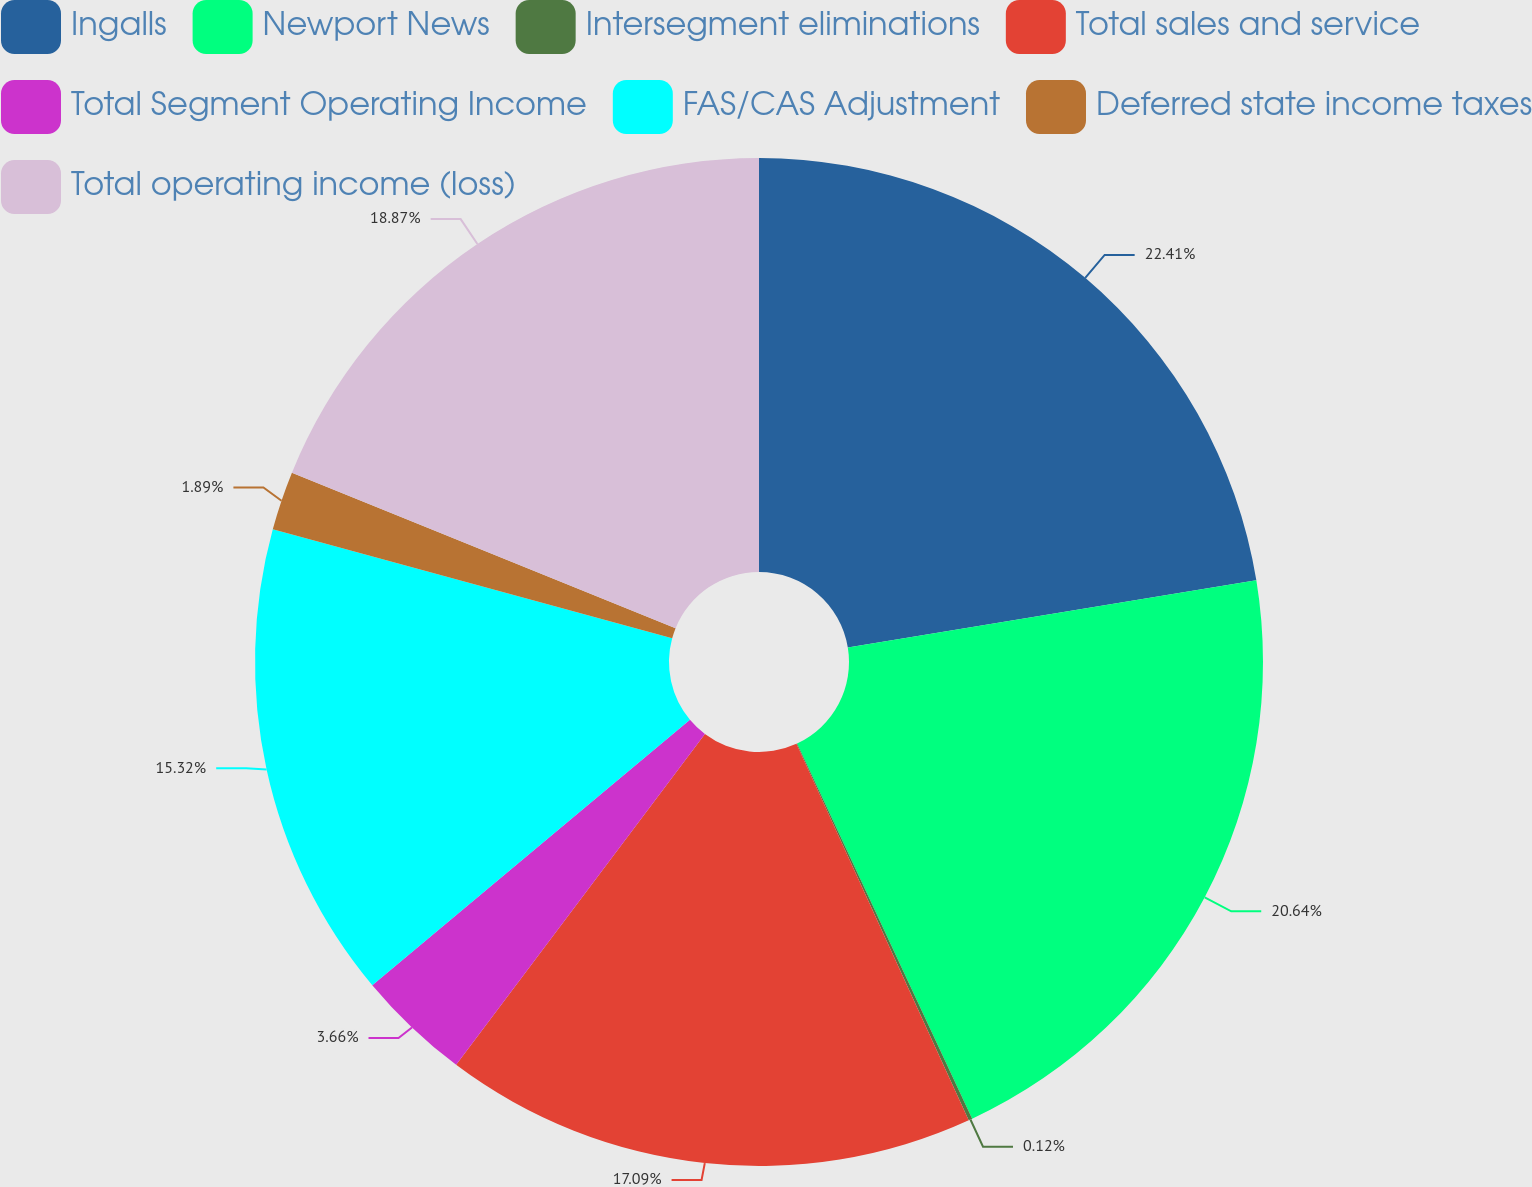Convert chart. <chart><loc_0><loc_0><loc_500><loc_500><pie_chart><fcel>Ingalls<fcel>Newport News<fcel>Intersegment eliminations<fcel>Total sales and service<fcel>Total Segment Operating Income<fcel>FAS/CAS Adjustment<fcel>Deferred state income taxes<fcel>Total operating income (loss)<nl><fcel>22.41%<fcel>20.64%<fcel>0.12%<fcel>17.09%<fcel>3.66%<fcel>15.32%<fcel>1.89%<fcel>18.87%<nl></chart> 